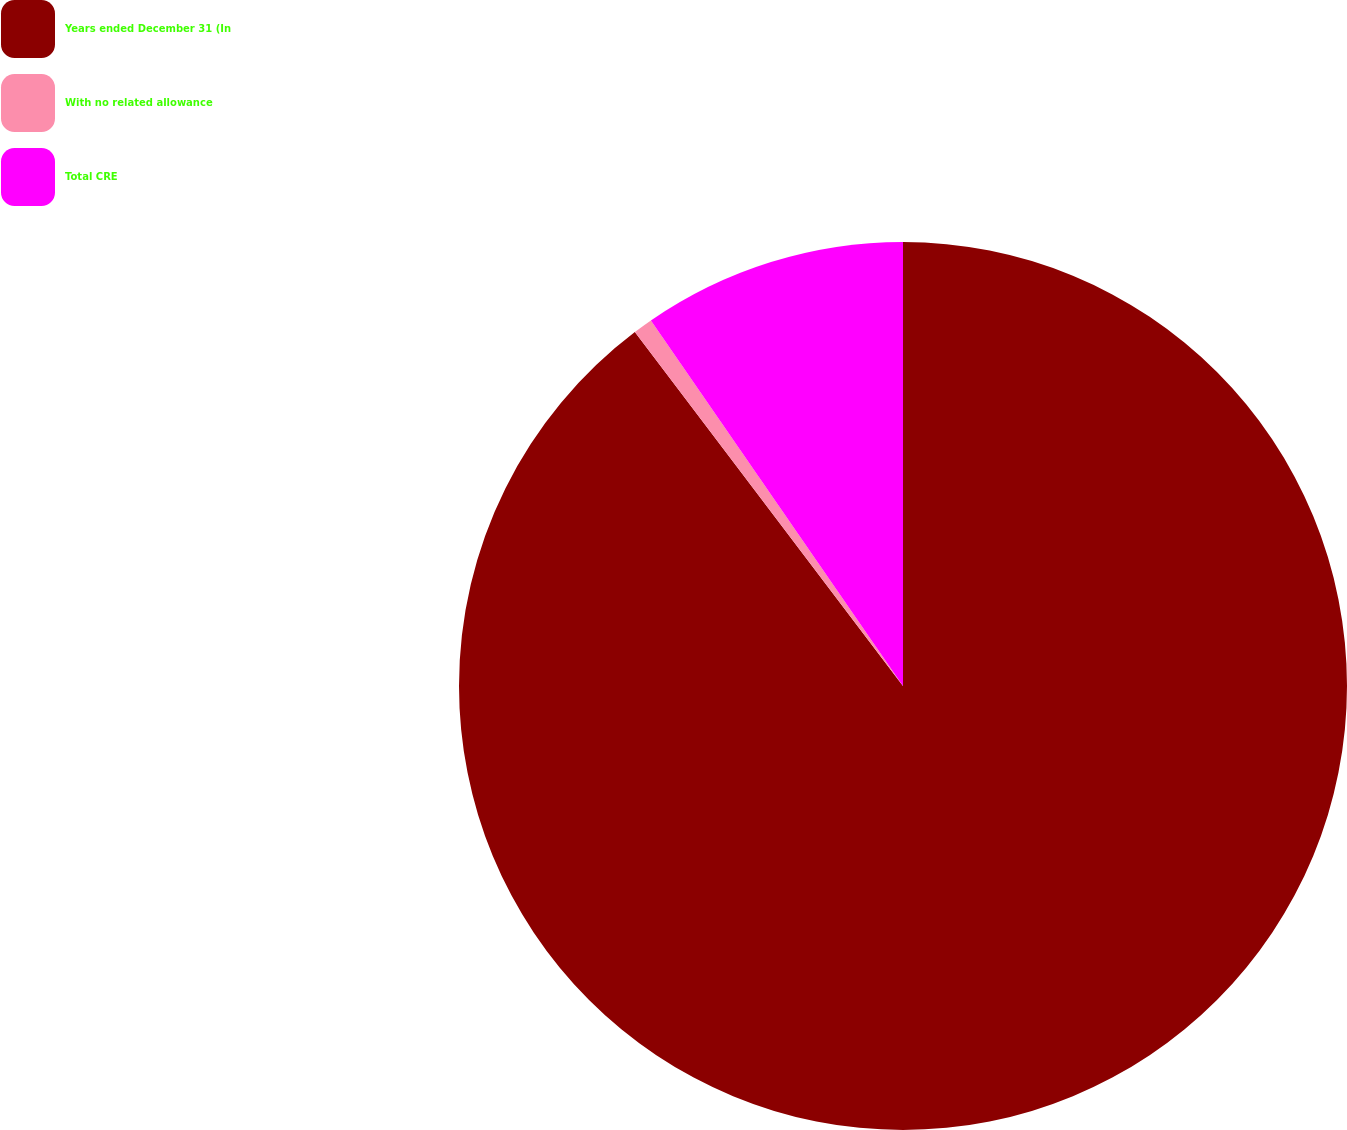Convert chart to OTSL. <chart><loc_0><loc_0><loc_500><loc_500><pie_chart><fcel>Years ended December 31 (In<fcel>With no related allowance<fcel>Total CRE<nl><fcel>89.68%<fcel>0.71%<fcel>9.61%<nl></chart> 